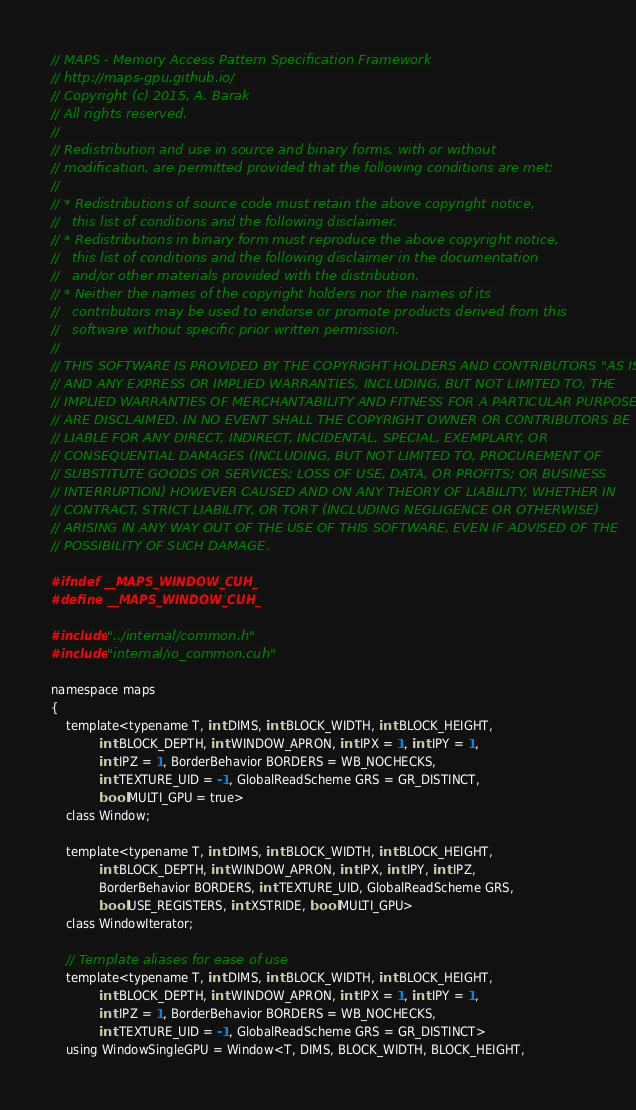<code> <loc_0><loc_0><loc_500><loc_500><_Cuda_>// MAPS - Memory Access Pattern Specification Framework
// http://maps-gpu.github.io/
// Copyright (c) 2015, A. Barak
// All rights reserved.
//
// Redistribution and use in source and binary forms, with or without
// modification, are permitted provided that the following conditions are met:
//
// * Redistributions of source code must retain the above copyright notice,
//   this list of conditions and the following disclaimer.
// * Redistributions in binary form must reproduce the above copyright notice,
//   this list of conditions and the following disclaimer in the documentation
//   and/or other materials provided with the distribution.
// * Neither the names of the copyright holders nor the names of its 
//   contributors may be used to endorse or promote products derived from this
//   software without specific prior written permission.
//
// THIS SOFTWARE IS PROVIDED BY THE COPYRIGHT HOLDERS AND CONTRIBUTORS "AS IS"
// AND ANY EXPRESS OR IMPLIED WARRANTIES, INCLUDING, BUT NOT LIMITED TO, THE
// IMPLIED WARRANTIES OF MERCHANTABILITY AND FITNESS FOR A PARTICULAR PURPOSE
// ARE DISCLAIMED. IN NO EVENT SHALL THE COPYRIGHT OWNER OR CONTRIBUTORS BE
// LIABLE FOR ANY DIRECT, INDIRECT, INCIDENTAL, SPECIAL, EXEMPLARY, OR
// CONSEQUENTIAL DAMAGES (INCLUDING, BUT NOT LIMITED TO, PROCUREMENT OF
// SUBSTITUTE GOODS OR SERVICES; LOSS OF USE, DATA, OR PROFITS; OR BUSINESS
// INTERRUPTION) HOWEVER CAUSED AND ON ANY THEORY OF LIABILITY, WHETHER IN
// CONTRACT, STRICT LIABILITY, OR TORT (INCLUDING NEGLIGENCE OR OTHERWISE)
// ARISING IN ANY WAY OUT OF THE USE OF THIS SOFTWARE, EVEN IF ADVISED OF THE
// POSSIBILITY OF SUCH DAMAGE.

#ifndef __MAPS_WINDOW_CUH_
#define __MAPS_WINDOW_CUH_

#include "../internal/common.h"
#include "internal/io_common.cuh"

namespace maps
{
    template<typename T, int DIMS, int BLOCK_WIDTH, int BLOCK_HEIGHT, 
             int BLOCK_DEPTH, int WINDOW_APRON, int IPX = 1, int IPY = 1, 
             int IPZ = 1, BorderBehavior BORDERS = WB_NOCHECKS, 
             int TEXTURE_UID = -1, GlobalReadScheme GRS = GR_DISTINCT, 
             bool MULTI_GPU = true>
    class Window;

    template<typename T, int DIMS, int BLOCK_WIDTH, int BLOCK_HEIGHT, 
             int BLOCK_DEPTH, int WINDOW_APRON, int IPX, int IPY, int IPZ, 
             BorderBehavior BORDERS, int TEXTURE_UID, GlobalReadScheme GRS, 
             bool USE_REGISTERS, int XSTRIDE, bool MULTI_GPU>
    class WindowIterator;

    // Template aliases for ease of use
    template<typename T, int DIMS, int BLOCK_WIDTH, int BLOCK_HEIGHT, 
             int BLOCK_DEPTH, int WINDOW_APRON, int IPX = 1, int IPY = 1, 
             int IPZ = 1, BorderBehavior BORDERS = WB_NOCHECKS, 
             int TEXTURE_UID = -1, GlobalReadScheme GRS = GR_DISTINCT>
    using WindowSingleGPU = Window<T, DIMS, BLOCK_WIDTH, BLOCK_HEIGHT, </code> 